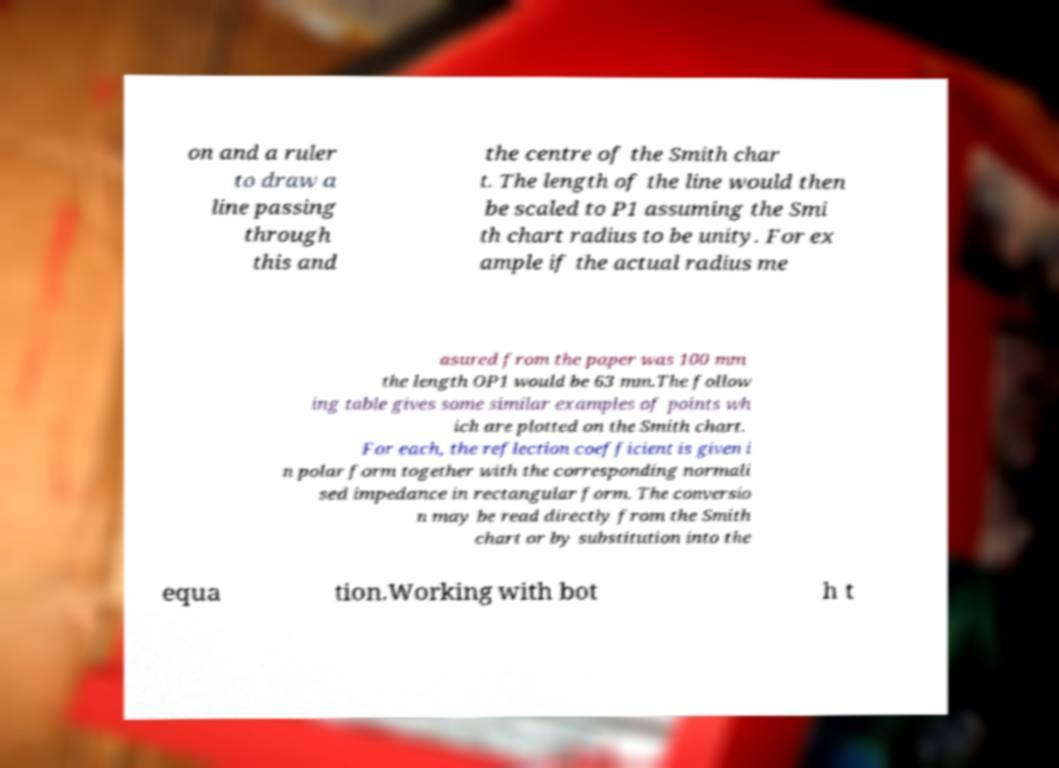Could you assist in decoding the text presented in this image and type it out clearly? on and a ruler to draw a line passing through this and the centre of the Smith char t. The length of the line would then be scaled to P1 assuming the Smi th chart radius to be unity. For ex ample if the actual radius me asured from the paper was 100 mm the length OP1 would be 63 mm.The follow ing table gives some similar examples of points wh ich are plotted on the Smith chart. For each, the reflection coefficient is given i n polar form together with the corresponding normali sed impedance in rectangular form. The conversio n may be read directly from the Smith chart or by substitution into the equa tion.Working with bot h t 